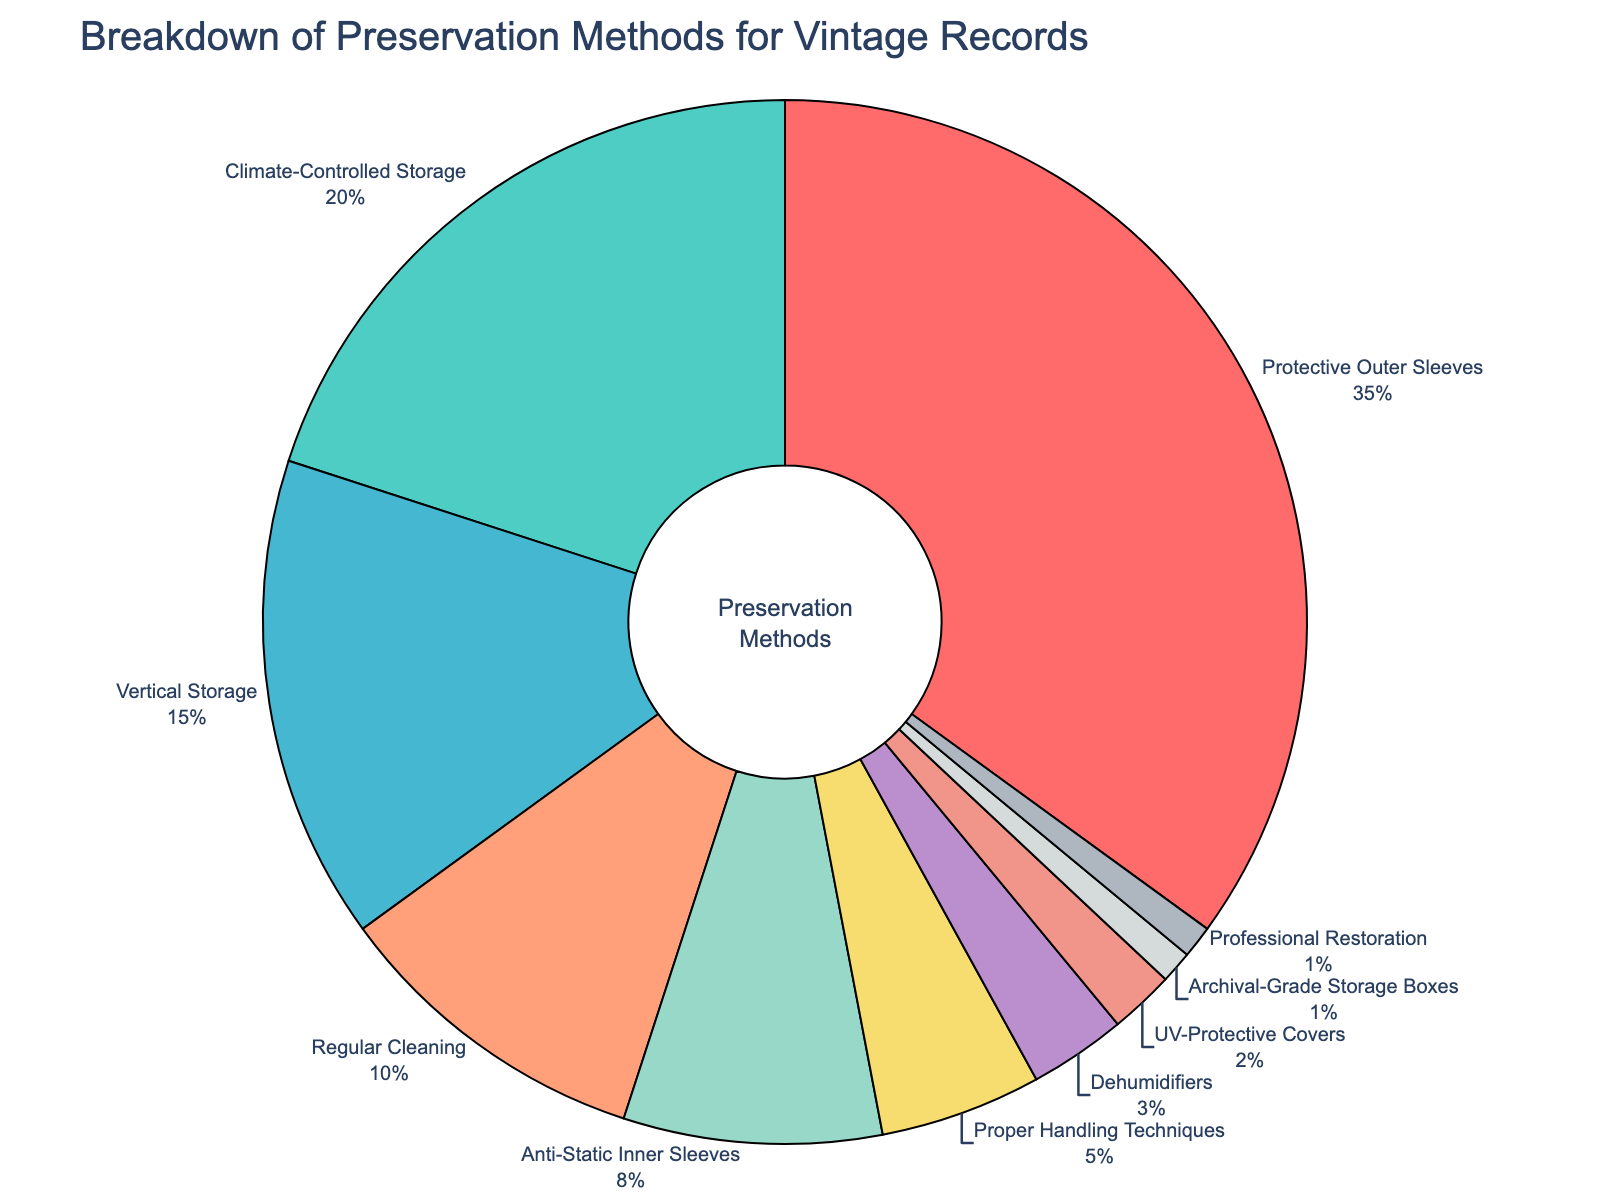What's the most common preservation method for vintage records? The pie chart shows different preservation methods and their corresponding percentages. The category with the highest percentage is the most common method. In this case, 'Protective Outer Sleeves' has the highest percentage of 35%.
Answer: Protective Outer Sleeves Which preservation method accounts for the smallest percentage? The pie chart shows the preservation methods and their percentages. The method with the smallest percentage is 'Professional Restoration' and 'Archival-Grade Storage Boxes', both with 1%.
Answer: Professional Restoration and Archival-Grade Storage Boxes How much more common are Protective Outer Sleeves compared to Climate-Controlled Storage? To find how much more common Protective Outer Sleeves are compared to Climate-Controlled Storage, subtract the percentage of Climate-Controlled Storage (20%) from Protective Outer Sleeves (35%). Therefore, 35% - 20% = 15%.
Answer: 15% What’s the combined percentage of Vertical Storage, Regular Cleaning, and Anti-Static Inner Sleeves? To find the combined percentage, add the percentages of Vertical Storage (15%), Regular Cleaning (10%), and Anti-Static Inner Sleeves (8%): 15% + 10% + 8% = 33%.
Answer: 33% Which two methods together contribute to 50% of the preservation methods used? Looking at the percentages, 'Protective Outer Sleeves' and 'Climate-Controlled Storage' together constitute 35% + 20% = 55%. This exceeds 50%. The next combination 'Protective Outer Sleeves' (35%) and 'Vertical Storage' (15%) together make exactly 50%.
Answer: Protective Outer Sleeves and Vertical Storage Are Anti-Static Inner Sleeves and Proper Handling Techniques combined more common than Climate-Controlled Storage? Add the percentages of Anti-Static Inner Sleeves (8%) and Proper Handling Techniques (5%), which give 8% + 5% = 13%. Compare this to Climate-Controlled Storage (20%), 13% is less than 20%.
Answer: No Which preservation method has a percentage closest to 10%? The pie chart shows 'Regular Cleaning' with a percentage of exactly 10%.
Answer: Regular Cleaning How many methods account for less than 5% each? The pie chart has 'Proper Handling Techniques' (5%), 'Dehumidifiers' (3%), 'UV-Protective Covers' (2%), 'Archival-Grade Storage Boxes' (1%), 'Professional Restoration' (1%). Among these, only methods with less than 5% are 'Dehumidifiers,' 'UV-Protective Covers,' 'Archival-Grade Storage Boxes,' and 'Professional Restoration'. This makes 4 methods.
Answer: 4 Which method represented in red has the highest percentage? The red slice of the pie chart represents 'Protective Outer Sleeves.' According to the chart, 'Protective Outer Sleeves' has the highest percentage of 35%.
Answer: Protective Outer Sleeves 